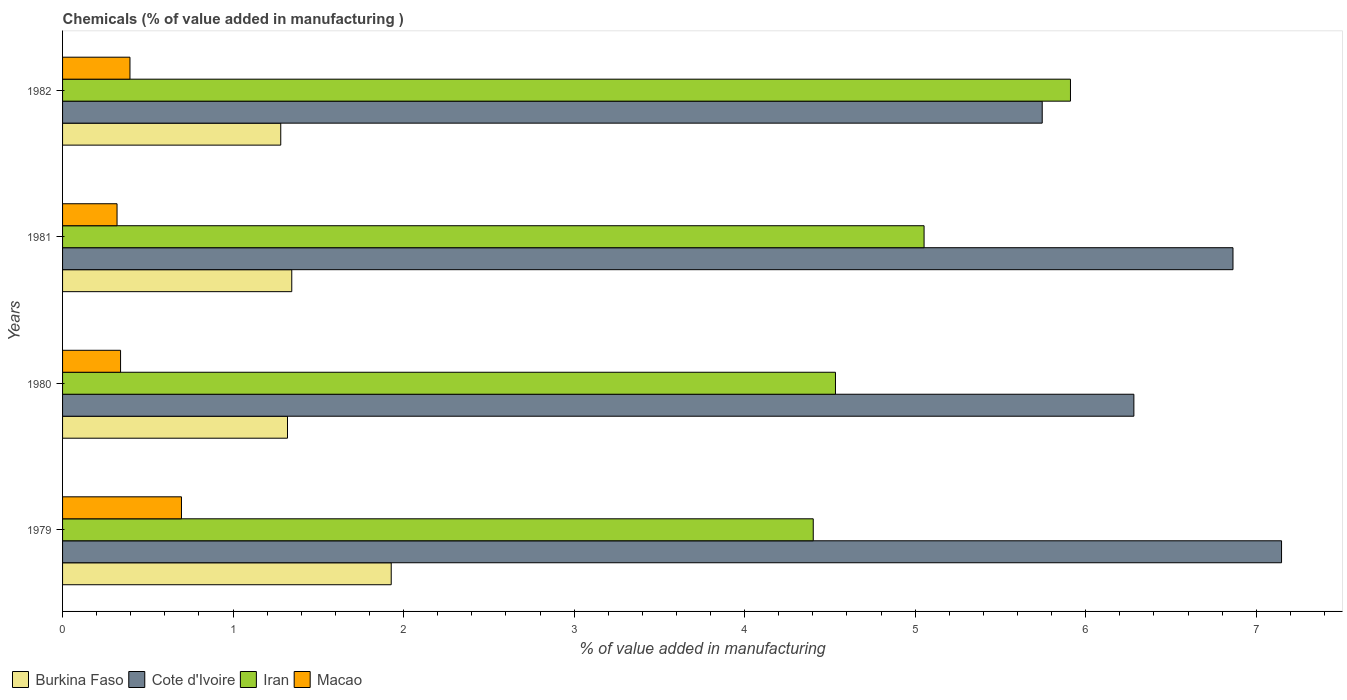Are the number of bars per tick equal to the number of legend labels?
Offer a very short reply. Yes. Are the number of bars on each tick of the Y-axis equal?
Offer a terse response. Yes. How many bars are there on the 4th tick from the top?
Give a very brief answer. 4. How many bars are there on the 1st tick from the bottom?
Ensure brevity in your answer.  4. What is the label of the 4th group of bars from the top?
Your answer should be compact. 1979. In how many cases, is the number of bars for a given year not equal to the number of legend labels?
Make the answer very short. 0. What is the value added in manufacturing chemicals in Burkina Faso in 1982?
Ensure brevity in your answer.  1.28. Across all years, what is the maximum value added in manufacturing chemicals in Burkina Faso?
Your answer should be compact. 1.93. Across all years, what is the minimum value added in manufacturing chemicals in Cote d'Ivoire?
Make the answer very short. 5.74. In which year was the value added in manufacturing chemicals in Cote d'Ivoire maximum?
Your response must be concise. 1979. What is the total value added in manufacturing chemicals in Macao in the graph?
Give a very brief answer. 1.75. What is the difference between the value added in manufacturing chemicals in Iran in 1980 and that in 1982?
Your answer should be compact. -1.38. What is the difference between the value added in manufacturing chemicals in Cote d'Ivoire in 1981 and the value added in manufacturing chemicals in Iran in 1979?
Your answer should be compact. 2.46. What is the average value added in manufacturing chemicals in Iran per year?
Offer a terse response. 4.97. In the year 1982, what is the difference between the value added in manufacturing chemicals in Burkina Faso and value added in manufacturing chemicals in Cote d'Ivoire?
Offer a terse response. -4.47. What is the ratio of the value added in manufacturing chemicals in Iran in 1981 to that in 1982?
Keep it short and to the point. 0.85. Is the value added in manufacturing chemicals in Macao in 1979 less than that in 1982?
Offer a terse response. No. Is the difference between the value added in manufacturing chemicals in Burkina Faso in 1979 and 1982 greater than the difference between the value added in manufacturing chemicals in Cote d'Ivoire in 1979 and 1982?
Provide a succinct answer. No. What is the difference between the highest and the second highest value added in manufacturing chemicals in Iran?
Give a very brief answer. 0.86. What is the difference between the highest and the lowest value added in manufacturing chemicals in Iran?
Your response must be concise. 1.51. In how many years, is the value added in manufacturing chemicals in Iran greater than the average value added in manufacturing chemicals in Iran taken over all years?
Your answer should be very brief. 2. What does the 4th bar from the top in 1981 represents?
Keep it short and to the point. Burkina Faso. What does the 3rd bar from the bottom in 1981 represents?
Offer a very short reply. Iran. What is the difference between two consecutive major ticks on the X-axis?
Provide a succinct answer. 1. Are the values on the major ticks of X-axis written in scientific E-notation?
Offer a very short reply. No. Does the graph contain grids?
Your answer should be compact. No. Where does the legend appear in the graph?
Ensure brevity in your answer.  Bottom left. How many legend labels are there?
Make the answer very short. 4. What is the title of the graph?
Make the answer very short. Chemicals (% of value added in manufacturing ). What is the label or title of the X-axis?
Your response must be concise. % of value added in manufacturing. What is the % of value added in manufacturing of Burkina Faso in 1979?
Make the answer very short. 1.93. What is the % of value added in manufacturing in Cote d'Ivoire in 1979?
Provide a succinct answer. 7.15. What is the % of value added in manufacturing of Iran in 1979?
Keep it short and to the point. 4.4. What is the % of value added in manufacturing in Macao in 1979?
Provide a succinct answer. 0.7. What is the % of value added in manufacturing in Burkina Faso in 1980?
Provide a short and direct response. 1.32. What is the % of value added in manufacturing of Cote d'Ivoire in 1980?
Ensure brevity in your answer.  6.28. What is the % of value added in manufacturing in Iran in 1980?
Keep it short and to the point. 4.53. What is the % of value added in manufacturing in Macao in 1980?
Provide a short and direct response. 0.34. What is the % of value added in manufacturing in Burkina Faso in 1981?
Keep it short and to the point. 1.34. What is the % of value added in manufacturing in Cote d'Ivoire in 1981?
Offer a very short reply. 6.86. What is the % of value added in manufacturing in Iran in 1981?
Provide a succinct answer. 5.05. What is the % of value added in manufacturing of Macao in 1981?
Provide a short and direct response. 0.32. What is the % of value added in manufacturing in Burkina Faso in 1982?
Give a very brief answer. 1.28. What is the % of value added in manufacturing in Cote d'Ivoire in 1982?
Your response must be concise. 5.74. What is the % of value added in manufacturing of Iran in 1982?
Provide a short and direct response. 5.91. What is the % of value added in manufacturing of Macao in 1982?
Keep it short and to the point. 0.4. Across all years, what is the maximum % of value added in manufacturing in Burkina Faso?
Ensure brevity in your answer.  1.93. Across all years, what is the maximum % of value added in manufacturing in Cote d'Ivoire?
Make the answer very short. 7.15. Across all years, what is the maximum % of value added in manufacturing in Iran?
Keep it short and to the point. 5.91. Across all years, what is the maximum % of value added in manufacturing of Macao?
Your answer should be very brief. 0.7. Across all years, what is the minimum % of value added in manufacturing of Burkina Faso?
Your response must be concise. 1.28. Across all years, what is the minimum % of value added in manufacturing of Cote d'Ivoire?
Ensure brevity in your answer.  5.74. Across all years, what is the minimum % of value added in manufacturing of Iran?
Offer a terse response. 4.4. Across all years, what is the minimum % of value added in manufacturing of Macao?
Keep it short and to the point. 0.32. What is the total % of value added in manufacturing in Burkina Faso in the graph?
Keep it short and to the point. 5.87. What is the total % of value added in manufacturing of Cote d'Ivoire in the graph?
Provide a succinct answer. 26.04. What is the total % of value added in manufacturing in Iran in the graph?
Your response must be concise. 19.9. What is the total % of value added in manufacturing in Macao in the graph?
Keep it short and to the point. 1.75. What is the difference between the % of value added in manufacturing in Burkina Faso in 1979 and that in 1980?
Keep it short and to the point. 0.61. What is the difference between the % of value added in manufacturing of Cote d'Ivoire in 1979 and that in 1980?
Provide a succinct answer. 0.87. What is the difference between the % of value added in manufacturing in Iran in 1979 and that in 1980?
Your answer should be very brief. -0.13. What is the difference between the % of value added in manufacturing in Macao in 1979 and that in 1980?
Provide a succinct answer. 0.36. What is the difference between the % of value added in manufacturing of Burkina Faso in 1979 and that in 1981?
Keep it short and to the point. 0.58. What is the difference between the % of value added in manufacturing in Cote d'Ivoire in 1979 and that in 1981?
Your answer should be compact. 0.28. What is the difference between the % of value added in manufacturing in Iran in 1979 and that in 1981?
Offer a terse response. -0.65. What is the difference between the % of value added in manufacturing of Macao in 1979 and that in 1981?
Offer a terse response. 0.38. What is the difference between the % of value added in manufacturing of Burkina Faso in 1979 and that in 1982?
Make the answer very short. 0.65. What is the difference between the % of value added in manufacturing in Cote d'Ivoire in 1979 and that in 1982?
Offer a terse response. 1.4. What is the difference between the % of value added in manufacturing in Iran in 1979 and that in 1982?
Provide a succinct answer. -1.51. What is the difference between the % of value added in manufacturing in Macao in 1979 and that in 1982?
Provide a succinct answer. 0.3. What is the difference between the % of value added in manufacturing of Burkina Faso in 1980 and that in 1981?
Your answer should be compact. -0.03. What is the difference between the % of value added in manufacturing of Cote d'Ivoire in 1980 and that in 1981?
Your answer should be compact. -0.58. What is the difference between the % of value added in manufacturing of Iran in 1980 and that in 1981?
Your answer should be very brief. -0.52. What is the difference between the % of value added in manufacturing of Macao in 1980 and that in 1981?
Ensure brevity in your answer.  0.02. What is the difference between the % of value added in manufacturing in Burkina Faso in 1980 and that in 1982?
Ensure brevity in your answer.  0.04. What is the difference between the % of value added in manufacturing of Cote d'Ivoire in 1980 and that in 1982?
Your response must be concise. 0.54. What is the difference between the % of value added in manufacturing of Iran in 1980 and that in 1982?
Make the answer very short. -1.38. What is the difference between the % of value added in manufacturing of Macao in 1980 and that in 1982?
Your response must be concise. -0.06. What is the difference between the % of value added in manufacturing in Burkina Faso in 1981 and that in 1982?
Your response must be concise. 0.06. What is the difference between the % of value added in manufacturing of Cote d'Ivoire in 1981 and that in 1982?
Your answer should be very brief. 1.12. What is the difference between the % of value added in manufacturing in Iran in 1981 and that in 1982?
Ensure brevity in your answer.  -0.86. What is the difference between the % of value added in manufacturing of Macao in 1981 and that in 1982?
Provide a short and direct response. -0.08. What is the difference between the % of value added in manufacturing in Burkina Faso in 1979 and the % of value added in manufacturing in Cote d'Ivoire in 1980?
Provide a short and direct response. -4.36. What is the difference between the % of value added in manufacturing in Burkina Faso in 1979 and the % of value added in manufacturing in Iran in 1980?
Provide a short and direct response. -2.61. What is the difference between the % of value added in manufacturing of Burkina Faso in 1979 and the % of value added in manufacturing of Macao in 1980?
Ensure brevity in your answer.  1.59. What is the difference between the % of value added in manufacturing in Cote d'Ivoire in 1979 and the % of value added in manufacturing in Iran in 1980?
Your answer should be very brief. 2.62. What is the difference between the % of value added in manufacturing of Cote d'Ivoire in 1979 and the % of value added in manufacturing of Macao in 1980?
Provide a succinct answer. 6.81. What is the difference between the % of value added in manufacturing in Iran in 1979 and the % of value added in manufacturing in Macao in 1980?
Keep it short and to the point. 4.06. What is the difference between the % of value added in manufacturing of Burkina Faso in 1979 and the % of value added in manufacturing of Cote d'Ivoire in 1981?
Provide a succinct answer. -4.94. What is the difference between the % of value added in manufacturing in Burkina Faso in 1979 and the % of value added in manufacturing in Iran in 1981?
Your response must be concise. -3.12. What is the difference between the % of value added in manufacturing of Burkina Faso in 1979 and the % of value added in manufacturing of Macao in 1981?
Your answer should be compact. 1.61. What is the difference between the % of value added in manufacturing in Cote d'Ivoire in 1979 and the % of value added in manufacturing in Iran in 1981?
Make the answer very short. 2.1. What is the difference between the % of value added in manufacturing of Cote d'Ivoire in 1979 and the % of value added in manufacturing of Macao in 1981?
Your answer should be compact. 6.83. What is the difference between the % of value added in manufacturing in Iran in 1979 and the % of value added in manufacturing in Macao in 1981?
Provide a short and direct response. 4.08. What is the difference between the % of value added in manufacturing in Burkina Faso in 1979 and the % of value added in manufacturing in Cote d'Ivoire in 1982?
Give a very brief answer. -3.82. What is the difference between the % of value added in manufacturing in Burkina Faso in 1979 and the % of value added in manufacturing in Iran in 1982?
Keep it short and to the point. -3.98. What is the difference between the % of value added in manufacturing of Burkina Faso in 1979 and the % of value added in manufacturing of Macao in 1982?
Offer a very short reply. 1.53. What is the difference between the % of value added in manufacturing in Cote d'Ivoire in 1979 and the % of value added in manufacturing in Iran in 1982?
Your response must be concise. 1.24. What is the difference between the % of value added in manufacturing in Cote d'Ivoire in 1979 and the % of value added in manufacturing in Macao in 1982?
Ensure brevity in your answer.  6.75. What is the difference between the % of value added in manufacturing of Iran in 1979 and the % of value added in manufacturing of Macao in 1982?
Offer a very short reply. 4.01. What is the difference between the % of value added in manufacturing in Burkina Faso in 1980 and the % of value added in manufacturing in Cote d'Ivoire in 1981?
Offer a very short reply. -5.54. What is the difference between the % of value added in manufacturing in Burkina Faso in 1980 and the % of value added in manufacturing in Iran in 1981?
Offer a terse response. -3.73. What is the difference between the % of value added in manufacturing of Cote d'Ivoire in 1980 and the % of value added in manufacturing of Iran in 1981?
Give a very brief answer. 1.23. What is the difference between the % of value added in manufacturing of Cote d'Ivoire in 1980 and the % of value added in manufacturing of Macao in 1981?
Offer a terse response. 5.96. What is the difference between the % of value added in manufacturing of Iran in 1980 and the % of value added in manufacturing of Macao in 1981?
Provide a short and direct response. 4.21. What is the difference between the % of value added in manufacturing in Burkina Faso in 1980 and the % of value added in manufacturing in Cote d'Ivoire in 1982?
Your answer should be compact. -4.43. What is the difference between the % of value added in manufacturing in Burkina Faso in 1980 and the % of value added in manufacturing in Iran in 1982?
Your answer should be very brief. -4.59. What is the difference between the % of value added in manufacturing of Burkina Faso in 1980 and the % of value added in manufacturing of Macao in 1982?
Give a very brief answer. 0.92. What is the difference between the % of value added in manufacturing of Cote d'Ivoire in 1980 and the % of value added in manufacturing of Iran in 1982?
Offer a very short reply. 0.37. What is the difference between the % of value added in manufacturing of Cote d'Ivoire in 1980 and the % of value added in manufacturing of Macao in 1982?
Provide a short and direct response. 5.89. What is the difference between the % of value added in manufacturing in Iran in 1980 and the % of value added in manufacturing in Macao in 1982?
Make the answer very short. 4.14. What is the difference between the % of value added in manufacturing in Burkina Faso in 1981 and the % of value added in manufacturing in Cote d'Ivoire in 1982?
Your response must be concise. -4.4. What is the difference between the % of value added in manufacturing of Burkina Faso in 1981 and the % of value added in manufacturing of Iran in 1982?
Offer a terse response. -4.57. What is the difference between the % of value added in manufacturing in Burkina Faso in 1981 and the % of value added in manufacturing in Macao in 1982?
Keep it short and to the point. 0.95. What is the difference between the % of value added in manufacturing of Cote d'Ivoire in 1981 and the % of value added in manufacturing of Iran in 1982?
Keep it short and to the point. 0.95. What is the difference between the % of value added in manufacturing in Cote d'Ivoire in 1981 and the % of value added in manufacturing in Macao in 1982?
Your answer should be very brief. 6.47. What is the difference between the % of value added in manufacturing of Iran in 1981 and the % of value added in manufacturing of Macao in 1982?
Your answer should be very brief. 4.66. What is the average % of value added in manufacturing of Burkina Faso per year?
Provide a succinct answer. 1.47. What is the average % of value added in manufacturing in Cote d'Ivoire per year?
Keep it short and to the point. 6.51. What is the average % of value added in manufacturing in Iran per year?
Keep it short and to the point. 4.97. What is the average % of value added in manufacturing of Macao per year?
Offer a very short reply. 0.44. In the year 1979, what is the difference between the % of value added in manufacturing of Burkina Faso and % of value added in manufacturing of Cote d'Ivoire?
Ensure brevity in your answer.  -5.22. In the year 1979, what is the difference between the % of value added in manufacturing of Burkina Faso and % of value added in manufacturing of Iran?
Make the answer very short. -2.47. In the year 1979, what is the difference between the % of value added in manufacturing in Burkina Faso and % of value added in manufacturing in Macao?
Make the answer very short. 1.23. In the year 1979, what is the difference between the % of value added in manufacturing of Cote d'Ivoire and % of value added in manufacturing of Iran?
Ensure brevity in your answer.  2.75. In the year 1979, what is the difference between the % of value added in manufacturing of Cote d'Ivoire and % of value added in manufacturing of Macao?
Offer a terse response. 6.45. In the year 1979, what is the difference between the % of value added in manufacturing of Iran and % of value added in manufacturing of Macao?
Offer a terse response. 3.7. In the year 1980, what is the difference between the % of value added in manufacturing of Burkina Faso and % of value added in manufacturing of Cote d'Ivoire?
Ensure brevity in your answer.  -4.96. In the year 1980, what is the difference between the % of value added in manufacturing in Burkina Faso and % of value added in manufacturing in Iran?
Provide a succinct answer. -3.21. In the year 1980, what is the difference between the % of value added in manufacturing of Cote d'Ivoire and % of value added in manufacturing of Iran?
Your answer should be compact. 1.75. In the year 1980, what is the difference between the % of value added in manufacturing in Cote d'Ivoire and % of value added in manufacturing in Macao?
Offer a terse response. 5.94. In the year 1980, what is the difference between the % of value added in manufacturing in Iran and % of value added in manufacturing in Macao?
Ensure brevity in your answer.  4.19. In the year 1981, what is the difference between the % of value added in manufacturing in Burkina Faso and % of value added in manufacturing in Cote d'Ivoire?
Your response must be concise. -5.52. In the year 1981, what is the difference between the % of value added in manufacturing of Burkina Faso and % of value added in manufacturing of Iran?
Make the answer very short. -3.71. In the year 1981, what is the difference between the % of value added in manufacturing in Burkina Faso and % of value added in manufacturing in Macao?
Ensure brevity in your answer.  1.02. In the year 1981, what is the difference between the % of value added in manufacturing in Cote d'Ivoire and % of value added in manufacturing in Iran?
Offer a terse response. 1.81. In the year 1981, what is the difference between the % of value added in manufacturing of Cote d'Ivoire and % of value added in manufacturing of Macao?
Offer a very short reply. 6.54. In the year 1981, what is the difference between the % of value added in manufacturing of Iran and % of value added in manufacturing of Macao?
Make the answer very short. 4.73. In the year 1982, what is the difference between the % of value added in manufacturing of Burkina Faso and % of value added in manufacturing of Cote d'Ivoire?
Give a very brief answer. -4.47. In the year 1982, what is the difference between the % of value added in manufacturing in Burkina Faso and % of value added in manufacturing in Iran?
Provide a succinct answer. -4.63. In the year 1982, what is the difference between the % of value added in manufacturing in Burkina Faso and % of value added in manufacturing in Macao?
Provide a short and direct response. 0.88. In the year 1982, what is the difference between the % of value added in manufacturing in Cote d'Ivoire and % of value added in manufacturing in Iran?
Give a very brief answer. -0.17. In the year 1982, what is the difference between the % of value added in manufacturing of Cote d'Ivoire and % of value added in manufacturing of Macao?
Ensure brevity in your answer.  5.35. In the year 1982, what is the difference between the % of value added in manufacturing of Iran and % of value added in manufacturing of Macao?
Your answer should be compact. 5.52. What is the ratio of the % of value added in manufacturing in Burkina Faso in 1979 to that in 1980?
Give a very brief answer. 1.46. What is the ratio of the % of value added in manufacturing of Cote d'Ivoire in 1979 to that in 1980?
Your answer should be very brief. 1.14. What is the ratio of the % of value added in manufacturing in Iran in 1979 to that in 1980?
Provide a succinct answer. 0.97. What is the ratio of the % of value added in manufacturing in Macao in 1979 to that in 1980?
Ensure brevity in your answer.  2.05. What is the ratio of the % of value added in manufacturing in Burkina Faso in 1979 to that in 1981?
Give a very brief answer. 1.43. What is the ratio of the % of value added in manufacturing in Cote d'Ivoire in 1979 to that in 1981?
Make the answer very short. 1.04. What is the ratio of the % of value added in manufacturing in Iran in 1979 to that in 1981?
Ensure brevity in your answer.  0.87. What is the ratio of the % of value added in manufacturing of Macao in 1979 to that in 1981?
Your answer should be very brief. 2.18. What is the ratio of the % of value added in manufacturing in Burkina Faso in 1979 to that in 1982?
Provide a succinct answer. 1.51. What is the ratio of the % of value added in manufacturing in Cote d'Ivoire in 1979 to that in 1982?
Make the answer very short. 1.24. What is the ratio of the % of value added in manufacturing in Iran in 1979 to that in 1982?
Offer a terse response. 0.74. What is the ratio of the % of value added in manufacturing of Macao in 1979 to that in 1982?
Your response must be concise. 1.76. What is the ratio of the % of value added in manufacturing in Burkina Faso in 1980 to that in 1981?
Make the answer very short. 0.98. What is the ratio of the % of value added in manufacturing in Cote d'Ivoire in 1980 to that in 1981?
Your response must be concise. 0.92. What is the ratio of the % of value added in manufacturing of Iran in 1980 to that in 1981?
Ensure brevity in your answer.  0.9. What is the ratio of the % of value added in manufacturing of Macao in 1980 to that in 1981?
Make the answer very short. 1.06. What is the ratio of the % of value added in manufacturing in Burkina Faso in 1980 to that in 1982?
Ensure brevity in your answer.  1.03. What is the ratio of the % of value added in manufacturing in Cote d'Ivoire in 1980 to that in 1982?
Provide a short and direct response. 1.09. What is the ratio of the % of value added in manufacturing of Iran in 1980 to that in 1982?
Make the answer very short. 0.77. What is the ratio of the % of value added in manufacturing of Macao in 1980 to that in 1982?
Make the answer very short. 0.86. What is the ratio of the % of value added in manufacturing of Burkina Faso in 1981 to that in 1982?
Your answer should be very brief. 1.05. What is the ratio of the % of value added in manufacturing of Cote d'Ivoire in 1981 to that in 1982?
Your response must be concise. 1.19. What is the ratio of the % of value added in manufacturing in Iran in 1981 to that in 1982?
Make the answer very short. 0.85. What is the ratio of the % of value added in manufacturing of Macao in 1981 to that in 1982?
Your response must be concise. 0.81. What is the difference between the highest and the second highest % of value added in manufacturing of Burkina Faso?
Offer a very short reply. 0.58. What is the difference between the highest and the second highest % of value added in manufacturing of Cote d'Ivoire?
Make the answer very short. 0.28. What is the difference between the highest and the second highest % of value added in manufacturing of Iran?
Keep it short and to the point. 0.86. What is the difference between the highest and the second highest % of value added in manufacturing in Macao?
Offer a very short reply. 0.3. What is the difference between the highest and the lowest % of value added in manufacturing in Burkina Faso?
Your answer should be very brief. 0.65. What is the difference between the highest and the lowest % of value added in manufacturing of Cote d'Ivoire?
Provide a short and direct response. 1.4. What is the difference between the highest and the lowest % of value added in manufacturing of Iran?
Your answer should be compact. 1.51. What is the difference between the highest and the lowest % of value added in manufacturing in Macao?
Your response must be concise. 0.38. 